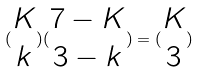Convert formula to latex. <formula><loc_0><loc_0><loc_500><loc_500>( \begin{matrix} K \\ k \end{matrix} ) ( \begin{matrix} 7 - K \\ 3 - k \end{matrix} ) = ( \begin{matrix} K \\ 3 \end{matrix} )</formula> 